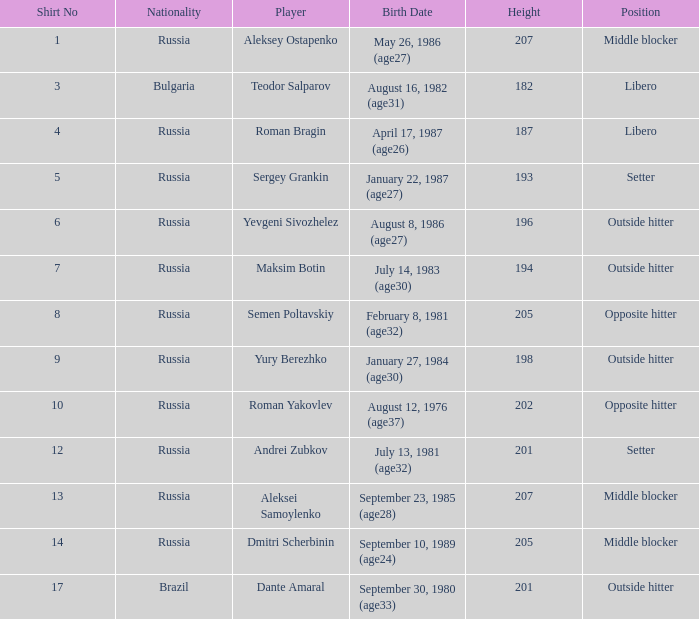What is maksim botin's designation? Outside hitter. 